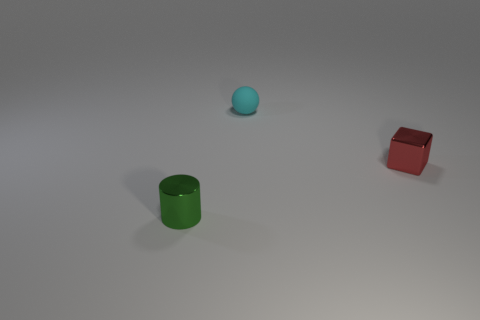Add 2 large cyan metallic blocks. How many objects exist? 5 Subtract all spheres. How many objects are left? 2 Subtract 0 brown cylinders. How many objects are left? 3 Subtract all small metallic objects. Subtract all tiny cyan metal cylinders. How many objects are left? 1 Add 1 tiny shiny cylinders. How many tiny shiny cylinders are left? 2 Add 1 red objects. How many red objects exist? 2 